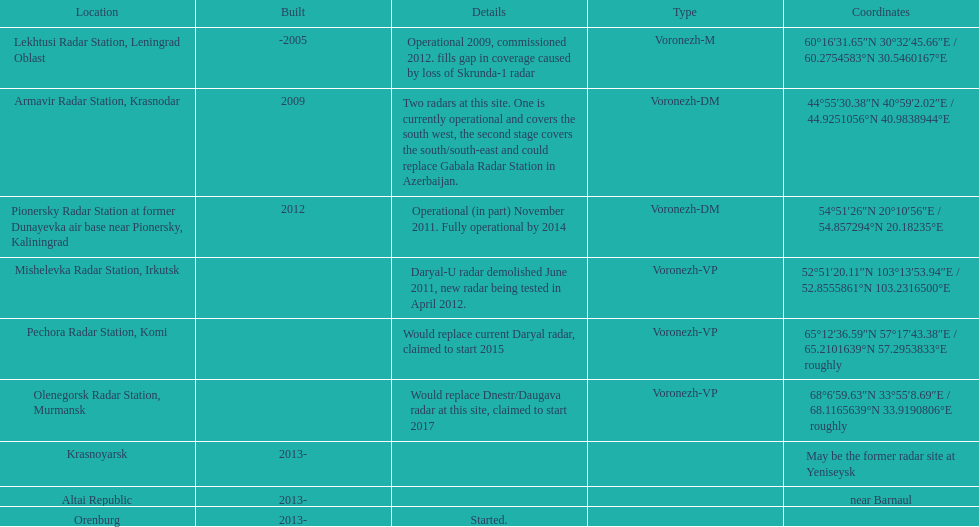How many voronezh radars were built before 2010? 2. Help me parse the entirety of this table. {'header': ['Location', 'Built', 'Details', 'Type', 'Coordinates'], 'rows': [['Lekhtusi Radar Station, Leningrad Oblast', '-2005', 'Operational 2009, commissioned 2012. fills gap in coverage caused by loss of Skrunda-1 radar', 'Voronezh-M', '60°16′31.65″N 30°32′45.66″E\ufeff / \ufeff60.2754583°N 30.5460167°E'], ['Armavir Radar Station, Krasnodar', '2009', 'Two radars at this site. One is currently operational and covers the south west, the second stage covers the south/south-east and could replace Gabala Radar Station in Azerbaijan.', 'Voronezh-DM', '44°55′30.38″N 40°59′2.02″E\ufeff / \ufeff44.9251056°N 40.9838944°E'], ['Pionersky Radar Station at former Dunayevka air base near Pionersky, Kaliningrad', '2012', 'Operational (in part) November 2011. Fully operational by 2014', 'Voronezh-DM', '54°51′26″N 20°10′56″E\ufeff / \ufeff54.857294°N 20.18235°E'], ['Mishelevka Radar Station, Irkutsk', '', 'Daryal-U radar demolished June 2011, new radar being tested in April 2012.', 'Voronezh-VP', '52°51′20.11″N 103°13′53.94″E\ufeff / \ufeff52.8555861°N 103.2316500°E'], ['Pechora Radar Station, Komi', '', 'Would replace current Daryal radar, claimed to start 2015', 'Voronezh-VP', '65°12′36.59″N 57°17′43.38″E\ufeff / \ufeff65.2101639°N 57.2953833°E roughly'], ['Olenegorsk Radar Station, Murmansk', '', 'Would replace Dnestr/Daugava radar at this site, claimed to start 2017', 'Voronezh-VP', '68°6′59.63″N 33°55′8.69″E\ufeff / \ufeff68.1165639°N 33.9190806°E roughly'], ['Krasnoyarsk', '2013-', '', '', 'May be the former radar site at Yeniseysk'], ['Altai Republic', '2013-', '', '', 'near Barnaul'], ['Orenburg', '2013-', 'Started.', '', '']]} 